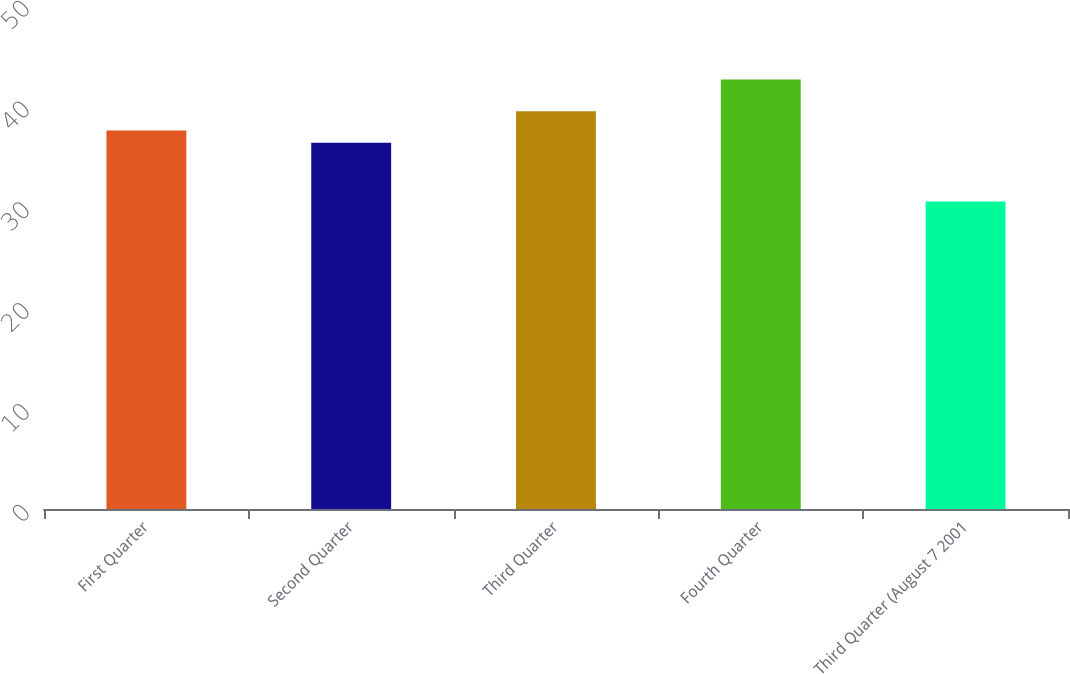Convert chart. <chart><loc_0><loc_0><loc_500><loc_500><bar_chart><fcel>First Quarter<fcel>Second Quarter<fcel>Third Quarter<fcel>Fourth Quarter<fcel>Third Quarter (August 7 2001<nl><fcel>37.55<fcel>36.34<fcel>39.46<fcel>42.6<fcel>30.5<nl></chart> 